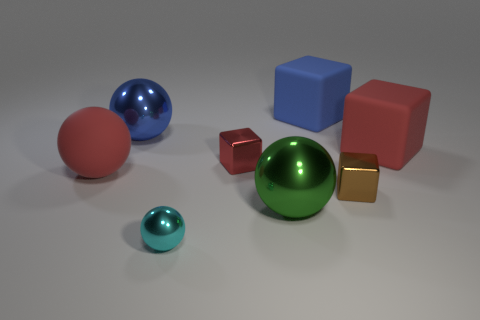Subtract all big balls. How many balls are left? 1 Add 1 tiny cyan metal cubes. How many objects exist? 9 Subtract all red balls. How many balls are left? 3 Add 4 red matte blocks. How many red matte blocks exist? 5 Subtract 0 purple blocks. How many objects are left? 8 Subtract 1 balls. How many balls are left? 3 Subtract all brown spheres. Subtract all brown cylinders. How many spheres are left? 4 Subtract all cyan blocks. How many green spheres are left? 1 Subtract all small red objects. Subtract all big spheres. How many objects are left? 4 Add 3 big blue cubes. How many big blue cubes are left? 4 